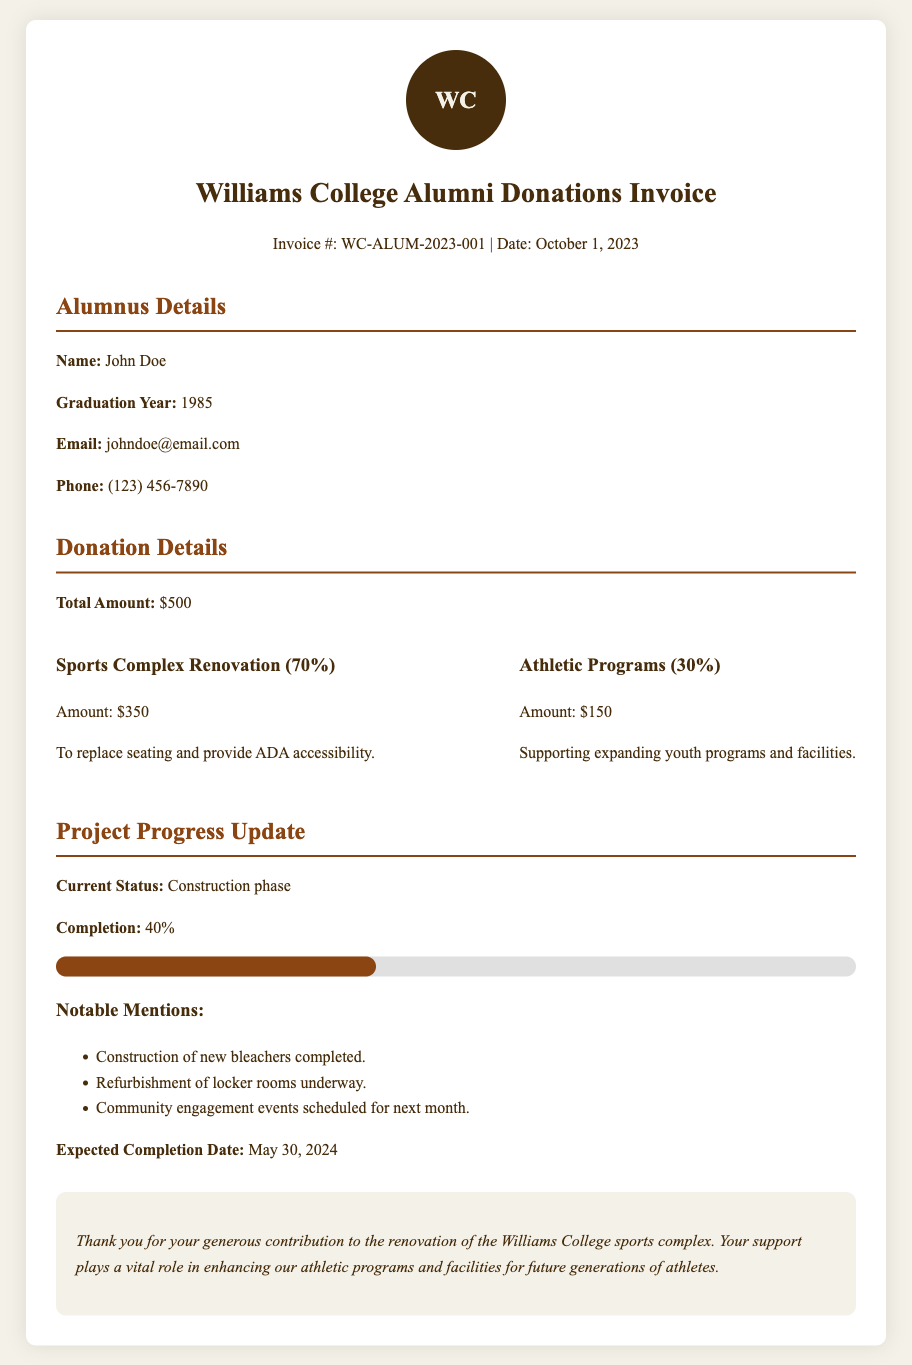What is the invoice number? The invoice number is listed at the top of the document as Invoice #: WC-ALUM-2023-001.
Answer: WC-ALUM-2023-001 What is the total donation amount? The total donation amount is specifically mentioned in the donation details section as $500.
Answer: $500 How much is allocated for the sports complex renovation? The document specifies that 70% of the total amount is allocated for sports complex renovation, which is $350.
Answer: $350 What percentage of the donation supports athletic programs? The document indicates that 30% of the total amount is directed towards athletic programs.
Answer: 30% What is the current status of the project? The current status of the project is mentioned in the project update section, which states "Construction phase."
Answer: Construction phase What is the expected completion date of the renovation? The expected completion date is provided in the project update section as May 30, 2024.
Answer: May 30, 2024 What is the completion percentage of the project? The document shows that the project is currently at 40% completion.
Answer: 40% What notable mention states that bleachers are completed? In the project update section, it mentions that "Construction of new bleachers completed."
Answer: Construction of new bleachers completed Who is the alumnus listed in the document? The alumnus details section lists "John Doe" as the name of the alumnus.
Answer: John Doe 